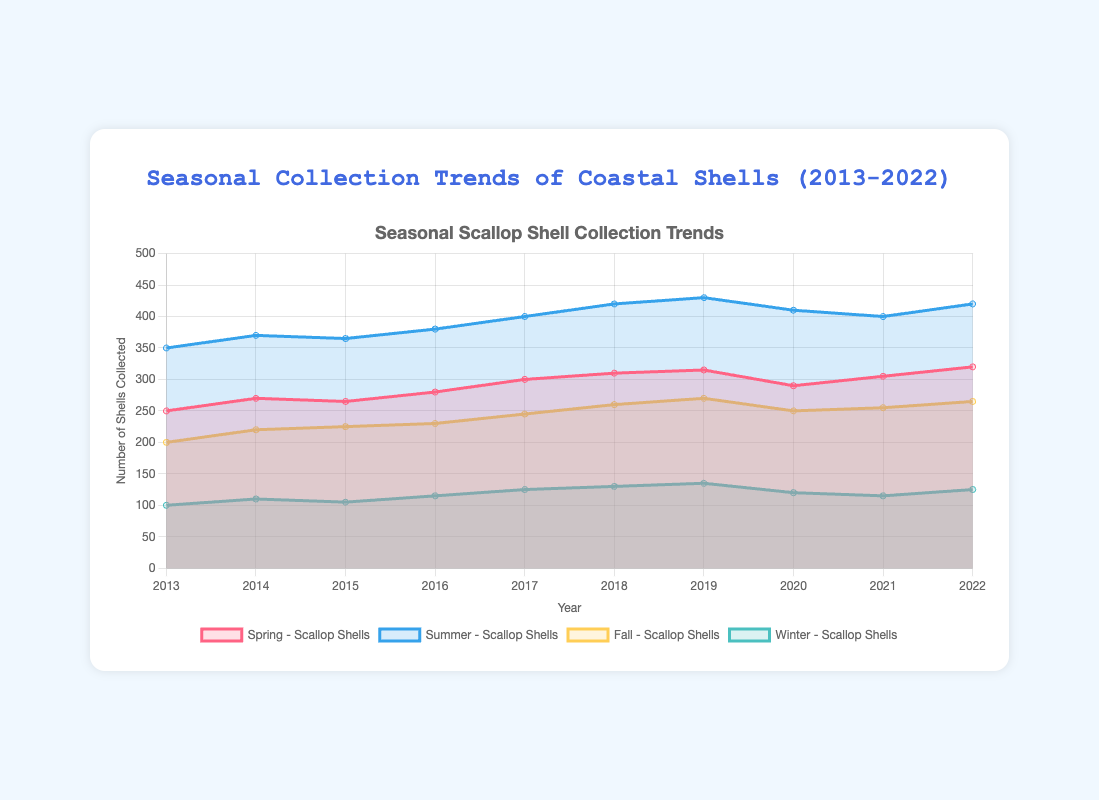What's the title of the chart? The title is displayed at the top center of the chart. It reads "Seasonal Collection Trends of Coastal Shells (2013-2022)"
Answer: Seasonal Collection Trends of Coastal Shells (2013-2022) In which season was the collection of Scallop Shells the highest in 2022? To find this, compare the collection numbers of Scallop Shells across Spring, Summer, Fall, and Winter for the year 2022. Summer shows the highest collection number.
Answer: Summer By looking at the trend, which type of shell had the most consistent increase in collection over the years during Spring? Check the "Spring" lines for all years and observe their trends. The lines for Spring display a steady increase, and the Scallop Shells line shows the most consistent rise.
Answer: Scallop Shells Which season and year had the highest number of Oyster Shell collections? Compare all the values of the Oyster Shell collections across each season and each year. In Summer 2019, the highest collection of 245 Oyster Shells was recorded.
Answer: Summer 2019 What's the average number of Conch Shells collected during the Winter season over the entire period? Sum the number of Conch Shells collected during Winter from 2013 to 2022 and divide by the number of years (10). The values are 40, 45, 50, 55, 60, 65, 70, 60, 55, and 50, summing to 550. Therefore, the average is 550 / 10 = 55.
Answer: 55 How does the number of Scallop Shells collected in Fall 2013 compare to Fall 2022? Check the values for Fall 2013 and Fall 2022 in the figure for Scallop Shells. Fall 2013 shows 200, and Fall 2022 shows 265. The numbers reveal an increase.
Answer: Increased During which year was the maximum number of Conch Shells collected in Summer, and how many were collected? Locate the Summer section in the Conch Shell segment across the years and find the peak value. The maximum number collected in Summer was 175 in the year 2022.
Answer: 2022, 175 